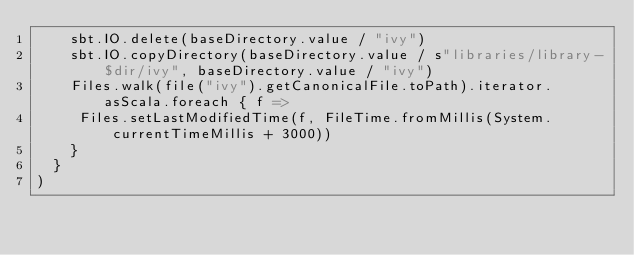Convert code to text. <code><loc_0><loc_0><loc_500><loc_500><_Scala_>    sbt.IO.delete(baseDirectory.value / "ivy")
    sbt.IO.copyDirectory(baseDirectory.value / s"libraries/library-$dir/ivy", baseDirectory.value / "ivy")
    Files.walk(file("ivy").getCanonicalFile.toPath).iterator.asScala.foreach { f =>
     Files.setLastModifiedTime(f, FileTime.fromMillis(System.currentTimeMillis + 3000))
    }
  }
)
</code> 